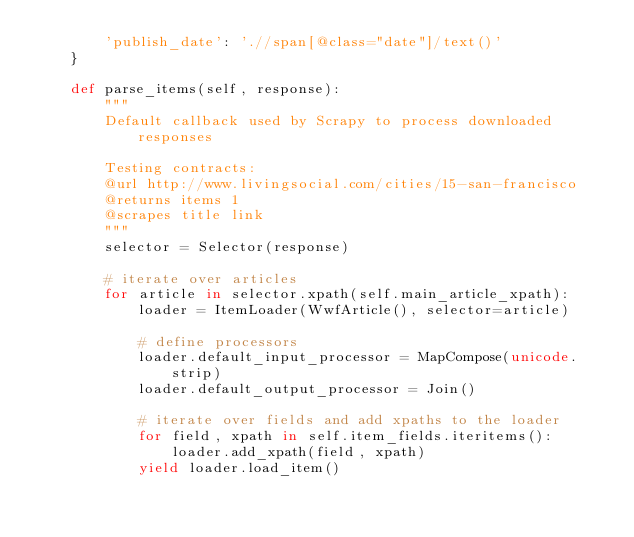Convert code to text. <code><loc_0><loc_0><loc_500><loc_500><_Python_>        'publish_date': './/span[@class="date"]/text()'
    }

    def parse_items(self, response):
        """
        Default callback used by Scrapy to process downloaded responses

        Testing contracts:
        @url http://www.livingsocial.com/cities/15-san-francisco
        @returns items 1
        @scrapes title link
        """
        selector = Selector(response)

        # iterate over articles
        for article in selector.xpath(self.main_article_xpath):
            loader = ItemLoader(WwfArticle(), selector=article)

            # define processors
            loader.default_input_processor = MapCompose(unicode.strip)
            loader.default_output_processor = Join()

            # iterate over fields and add xpaths to the loader
            for field, xpath in self.item_fields.iteritems():
                loader.add_xpath(field, xpath)
            yield loader.load_item()
</code> 